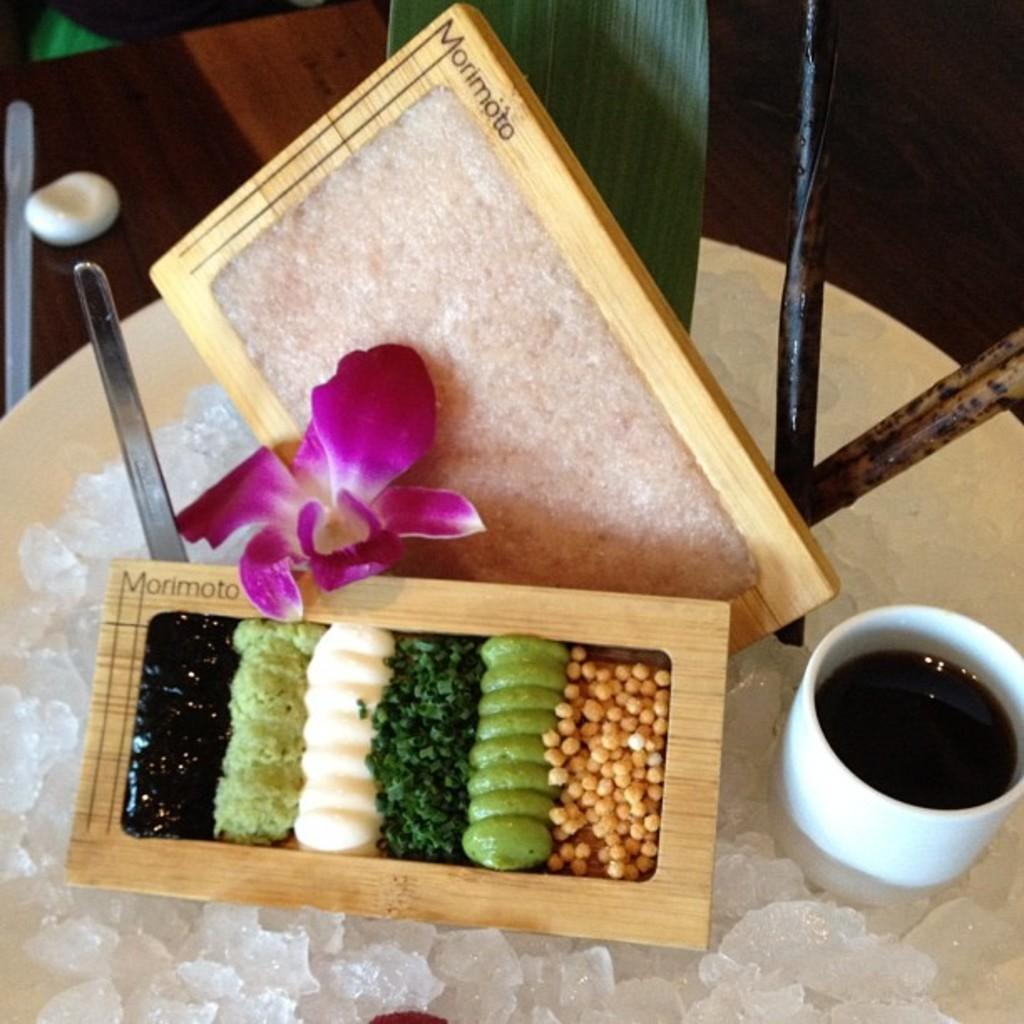What is contained in the box that is visible in the image? There is food in a box in the image. What is on the plate in the image? There is ice in a plate in the image. What is in the cup in the image? There is sauce in a cup in the image. What utensil is on the table in the image? There is a spoon on the table in the image. What type of plant is present in the image? There is a leaf and a flower in the image. What type of juice can be seen in the image? There is no juice present in the image. How many yards are visible in the image? There is no yard present in the image; it is not an outdoor scene. 